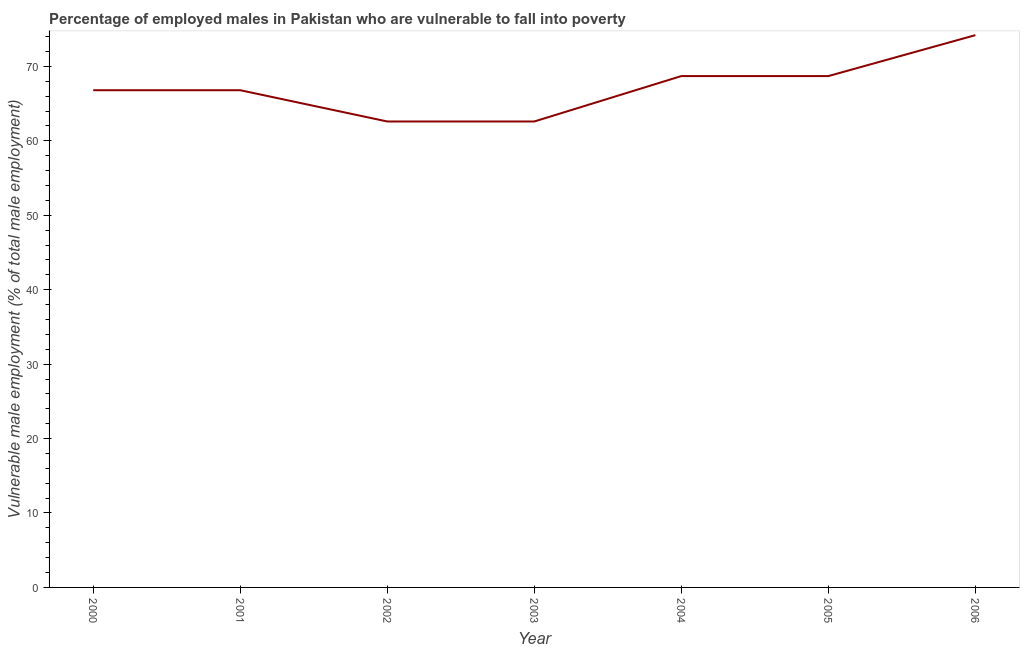What is the percentage of employed males who are vulnerable to fall into poverty in 2006?
Make the answer very short. 74.2. Across all years, what is the maximum percentage of employed males who are vulnerable to fall into poverty?
Give a very brief answer. 74.2. Across all years, what is the minimum percentage of employed males who are vulnerable to fall into poverty?
Provide a succinct answer. 62.6. In which year was the percentage of employed males who are vulnerable to fall into poverty maximum?
Give a very brief answer. 2006. What is the sum of the percentage of employed males who are vulnerable to fall into poverty?
Your answer should be very brief. 470.4. What is the difference between the percentage of employed males who are vulnerable to fall into poverty in 2000 and 2001?
Offer a very short reply. 0. What is the average percentage of employed males who are vulnerable to fall into poverty per year?
Your answer should be compact. 67.2. What is the median percentage of employed males who are vulnerable to fall into poverty?
Provide a succinct answer. 66.8. What is the ratio of the percentage of employed males who are vulnerable to fall into poverty in 2000 to that in 2004?
Your response must be concise. 0.97. Is the percentage of employed males who are vulnerable to fall into poverty in 2004 less than that in 2005?
Your response must be concise. No. Is the difference between the percentage of employed males who are vulnerable to fall into poverty in 2002 and 2004 greater than the difference between any two years?
Make the answer very short. No. What is the difference between the highest and the lowest percentage of employed males who are vulnerable to fall into poverty?
Offer a terse response. 11.6. In how many years, is the percentage of employed males who are vulnerable to fall into poverty greater than the average percentage of employed males who are vulnerable to fall into poverty taken over all years?
Your response must be concise. 3. Does the percentage of employed males who are vulnerable to fall into poverty monotonically increase over the years?
Provide a succinct answer. No. How many lines are there?
Offer a very short reply. 1. How many years are there in the graph?
Offer a terse response. 7. What is the difference between two consecutive major ticks on the Y-axis?
Ensure brevity in your answer.  10. Does the graph contain any zero values?
Give a very brief answer. No. Does the graph contain grids?
Give a very brief answer. No. What is the title of the graph?
Provide a succinct answer. Percentage of employed males in Pakistan who are vulnerable to fall into poverty. What is the label or title of the Y-axis?
Keep it short and to the point. Vulnerable male employment (% of total male employment). What is the Vulnerable male employment (% of total male employment) of 2000?
Offer a very short reply. 66.8. What is the Vulnerable male employment (% of total male employment) in 2001?
Your answer should be compact. 66.8. What is the Vulnerable male employment (% of total male employment) in 2002?
Your answer should be very brief. 62.6. What is the Vulnerable male employment (% of total male employment) in 2003?
Your answer should be very brief. 62.6. What is the Vulnerable male employment (% of total male employment) in 2004?
Offer a terse response. 68.7. What is the Vulnerable male employment (% of total male employment) of 2005?
Give a very brief answer. 68.7. What is the Vulnerable male employment (% of total male employment) of 2006?
Keep it short and to the point. 74.2. What is the difference between the Vulnerable male employment (% of total male employment) in 2000 and 2001?
Your answer should be very brief. 0. What is the difference between the Vulnerable male employment (% of total male employment) in 2000 and 2003?
Keep it short and to the point. 4.2. What is the difference between the Vulnerable male employment (% of total male employment) in 2000 and 2004?
Offer a terse response. -1.9. What is the difference between the Vulnerable male employment (% of total male employment) in 2000 and 2005?
Your response must be concise. -1.9. What is the difference between the Vulnerable male employment (% of total male employment) in 2000 and 2006?
Your response must be concise. -7.4. What is the difference between the Vulnerable male employment (% of total male employment) in 2001 and 2002?
Your response must be concise. 4.2. What is the difference between the Vulnerable male employment (% of total male employment) in 2001 and 2003?
Give a very brief answer. 4.2. What is the difference between the Vulnerable male employment (% of total male employment) in 2001 and 2004?
Provide a short and direct response. -1.9. What is the difference between the Vulnerable male employment (% of total male employment) in 2001 and 2005?
Provide a short and direct response. -1.9. What is the difference between the Vulnerable male employment (% of total male employment) in 2001 and 2006?
Offer a very short reply. -7.4. What is the difference between the Vulnerable male employment (% of total male employment) in 2002 and 2003?
Make the answer very short. 0. What is the difference between the Vulnerable male employment (% of total male employment) in 2002 and 2005?
Ensure brevity in your answer.  -6.1. What is the difference between the Vulnerable male employment (% of total male employment) in 2002 and 2006?
Your answer should be very brief. -11.6. What is the difference between the Vulnerable male employment (% of total male employment) in 2003 and 2004?
Offer a very short reply. -6.1. What is the difference between the Vulnerable male employment (% of total male employment) in 2003 and 2006?
Ensure brevity in your answer.  -11.6. What is the difference between the Vulnerable male employment (% of total male employment) in 2005 and 2006?
Your response must be concise. -5.5. What is the ratio of the Vulnerable male employment (% of total male employment) in 2000 to that in 2001?
Your response must be concise. 1. What is the ratio of the Vulnerable male employment (% of total male employment) in 2000 to that in 2002?
Provide a short and direct response. 1.07. What is the ratio of the Vulnerable male employment (% of total male employment) in 2000 to that in 2003?
Offer a terse response. 1.07. What is the ratio of the Vulnerable male employment (% of total male employment) in 2000 to that in 2005?
Keep it short and to the point. 0.97. What is the ratio of the Vulnerable male employment (% of total male employment) in 2001 to that in 2002?
Offer a very short reply. 1.07. What is the ratio of the Vulnerable male employment (% of total male employment) in 2001 to that in 2003?
Give a very brief answer. 1.07. What is the ratio of the Vulnerable male employment (% of total male employment) in 2001 to that in 2004?
Provide a succinct answer. 0.97. What is the ratio of the Vulnerable male employment (% of total male employment) in 2001 to that in 2006?
Ensure brevity in your answer.  0.9. What is the ratio of the Vulnerable male employment (% of total male employment) in 2002 to that in 2004?
Provide a succinct answer. 0.91. What is the ratio of the Vulnerable male employment (% of total male employment) in 2002 to that in 2005?
Ensure brevity in your answer.  0.91. What is the ratio of the Vulnerable male employment (% of total male employment) in 2002 to that in 2006?
Ensure brevity in your answer.  0.84. What is the ratio of the Vulnerable male employment (% of total male employment) in 2003 to that in 2004?
Give a very brief answer. 0.91. What is the ratio of the Vulnerable male employment (% of total male employment) in 2003 to that in 2005?
Provide a succinct answer. 0.91. What is the ratio of the Vulnerable male employment (% of total male employment) in 2003 to that in 2006?
Your answer should be compact. 0.84. What is the ratio of the Vulnerable male employment (% of total male employment) in 2004 to that in 2005?
Provide a succinct answer. 1. What is the ratio of the Vulnerable male employment (% of total male employment) in 2004 to that in 2006?
Offer a terse response. 0.93. What is the ratio of the Vulnerable male employment (% of total male employment) in 2005 to that in 2006?
Your answer should be very brief. 0.93. 